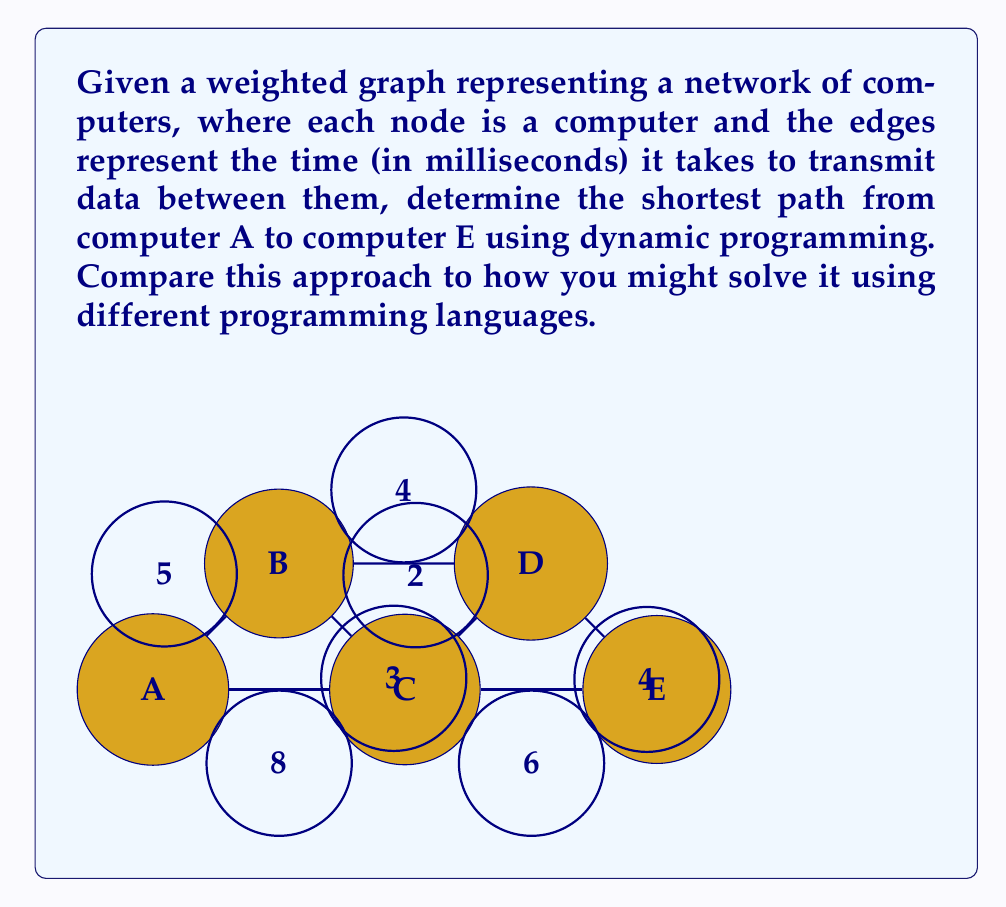Solve this math problem. To solve this problem using dynamic programming, we'll use the following steps:

1) Initialize distances:
   Let $d[v]$ be the shortest distance from A to vertex $v$.
   Set $d[A] = 0$ and $d[v] = \infty$ for all other vertices.

2) Create a predecessor array $pred[]$ to store the optimal path.

3) Iterate through all edges $(u,v)$ with weight $w$ and update:
   If $d[v] > d[u] + w$, then:
   $d[v] = d[u] + w$
   $pred[v] = u$

4) Repeat step 3 until no updates occur.

Let's apply this to our graph:

Iteration 1:
$d[B] = d[A] + 5 = 5$, $pred[B] = A$
$d[C] = d[A] + 8 = 8$, $pred[C] = A$

Iteration 2:
$d[C] = \min(d[C], d[B] + 3) = \min(8, 8) = 8$, $pred[C]$ unchanged
$d[D] = d[B] + 4 = 9$, $pred[D] = B$

Iteration 3:
$d[D] = \min(d[D], d[C] + 2) = \min(9, 10) = 9$, $pred[D]$ unchanged
$d[E] = d[C] + 6 = 14$, $pred[E] = C$

Iteration 4:
$d[E] = \min(d[E], d[D] + 4) = \min(14, 13) = 13$, $pred[E] = D$

The optimal path is found by backtracking through $pred[]$: E → D → B → A

In different programming languages, this could be implemented using various data structures:
- Python: Use dictionaries for $d[]$ and $pred[]$
- Java: Use HashMap or array for $d[]$ and $pred[]$
- C++: Use std::map or array for $d[]$ and $pred[]$

The core algorithm remains the same, but the implementation details may vary.
Answer: 13 ms; Path: A → B → D → E 